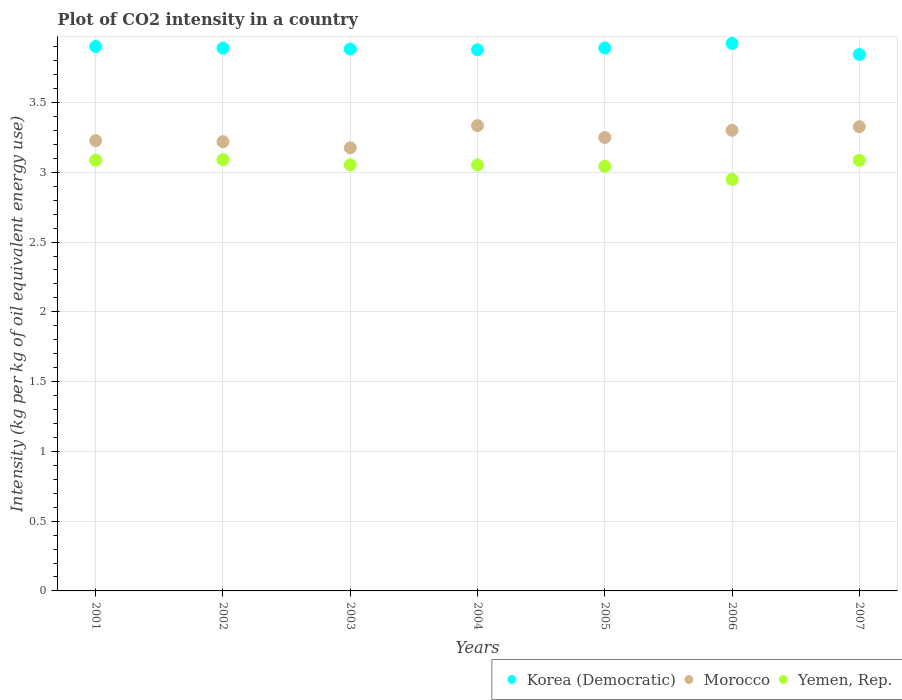What is the CO2 intensity in in Yemen, Rep. in 2001?
Ensure brevity in your answer.  3.09. Across all years, what is the maximum CO2 intensity in in Korea (Democratic)?
Ensure brevity in your answer.  3.92. Across all years, what is the minimum CO2 intensity in in Yemen, Rep.?
Give a very brief answer. 2.95. In which year was the CO2 intensity in in Yemen, Rep. maximum?
Provide a short and direct response. 2002. What is the total CO2 intensity in in Yemen, Rep. in the graph?
Keep it short and to the point. 21.36. What is the difference between the CO2 intensity in in Yemen, Rep. in 2003 and that in 2005?
Your answer should be very brief. 0.01. What is the difference between the CO2 intensity in in Korea (Democratic) in 2001 and the CO2 intensity in in Yemen, Rep. in 2007?
Keep it short and to the point. 0.82. What is the average CO2 intensity in in Yemen, Rep. per year?
Keep it short and to the point. 3.05. In the year 2007, what is the difference between the CO2 intensity in in Yemen, Rep. and CO2 intensity in in Korea (Democratic)?
Your answer should be compact. -0.76. In how many years, is the CO2 intensity in in Korea (Democratic) greater than 3 kg?
Make the answer very short. 7. What is the ratio of the CO2 intensity in in Morocco in 2003 to that in 2004?
Offer a very short reply. 0.95. Is the CO2 intensity in in Yemen, Rep. in 2003 less than that in 2005?
Provide a short and direct response. No. Is the difference between the CO2 intensity in in Yemen, Rep. in 2001 and 2007 greater than the difference between the CO2 intensity in in Korea (Democratic) in 2001 and 2007?
Make the answer very short. No. What is the difference between the highest and the second highest CO2 intensity in in Korea (Democratic)?
Offer a terse response. 0.02. What is the difference between the highest and the lowest CO2 intensity in in Yemen, Rep.?
Give a very brief answer. 0.14. Does the CO2 intensity in in Korea (Democratic) monotonically increase over the years?
Your answer should be very brief. No. Is the CO2 intensity in in Korea (Democratic) strictly greater than the CO2 intensity in in Yemen, Rep. over the years?
Your response must be concise. Yes. How many dotlines are there?
Keep it short and to the point. 3. Are the values on the major ticks of Y-axis written in scientific E-notation?
Give a very brief answer. No. Does the graph contain any zero values?
Keep it short and to the point. No. Where does the legend appear in the graph?
Ensure brevity in your answer.  Bottom right. What is the title of the graph?
Provide a short and direct response. Plot of CO2 intensity in a country. What is the label or title of the Y-axis?
Your answer should be compact. Intensity (kg per kg of oil equivalent energy use). What is the Intensity (kg per kg of oil equivalent energy use) in Korea (Democratic) in 2001?
Provide a succinct answer. 3.9. What is the Intensity (kg per kg of oil equivalent energy use) of Morocco in 2001?
Your response must be concise. 3.23. What is the Intensity (kg per kg of oil equivalent energy use) of Yemen, Rep. in 2001?
Offer a terse response. 3.09. What is the Intensity (kg per kg of oil equivalent energy use) of Korea (Democratic) in 2002?
Provide a short and direct response. 3.89. What is the Intensity (kg per kg of oil equivalent energy use) in Morocco in 2002?
Make the answer very short. 3.22. What is the Intensity (kg per kg of oil equivalent energy use) of Yemen, Rep. in 2002?
Offer a very short reply. 3.09. What is the Intensity (kg per kg of oil equivalent energy use) in Korea (Democratic) in 2003?
Keep it short and to the point. 3.88. What is the Intensity (kg per kg of oil equivalent energy use) of Morocco in 2003?
Make the answer very short. 3.18. What is the Intensity (kg per kg of oil equivalent energy use) of Yemen, Rep. in 2003?
Offer a terse response. 3.05. What is the Intensity (kg per kg of oil equivalent energy use) in Korea (Democratic) in 2004?
Your answer should be compact. 3.88. What is the Intensity (kg per kg of oil equivalent energy use) in Morocco in 2004?
Your answer should be very brief. 3.33. What is the Intensity (kg per kg of oil equivalent energy use) of Yemen, Rep. in 2004?
Provide a succinct answer. 3.05. What is the Intensity (kg per kg of oil equivalent energy use) of Korea (Democratic) in 2005?
Offer a terse response. 3.89. What is the Intensity (kg per kg of oil equivalent energy use) of Morocco in 2005?
Ensure brevity in your answer.  3.25. What is the Intensity (kg per kg of oil equivalent energy use) of Yemen, Rep. in 2005?
Your answer should be compact. 3.04. What is the Intensity (kg per kg of oil equivalent energy use) of Korea (Democratic) in 2006?
Your answer should be very brief. 3.92. What is the Intensity (kg per kg of oil equivalent energy use) of Morocco in 2006?
Offer a very short reply. 3.3. What is the Intensity (kg per kg of oil equivalent energy use) in Yemen, Rep. in 2006?
Give a very brief answer. 2.95. What is the Intensity (kg per kg of oil equivalent energy use) in Korea (Democratic) in 2007?
Offer a terse response. 3.84. What is the Intensity (kg per kg of oil equivalent energy use) in Morocco in 2007?
Ensure brevity in your answer.  3.33. What is the Intensity (kg per kg of oil equivalent energy use) in Yemen, Rep. in 2007?
Offer a very short reply. 3.09. Across all years, what is the maximum Intensity (kg per kg of oil equivalent energy use) of Korea (Democratic)?
Provide a short and direct response. 3.92. Across all years, what is the maximum Intensity (kg per kg of oil equivalent energy use) of Morocco?
Ensure brevity in your answer.  3.33. Across all years, what is the maximum Intensity (kg per kg of oil equivalent energy use) of Yemen, Rep.?
Give a very brief answer. 3.09. Across all years, what is the minimum Intensity (kg per kg of oil equivalent energy use) in Korea (Democratic)?
Ensure brevity in your answer.  3.84. Across all years, what is the minimum Intensity (kg per kg of oil equivalent energy use) of Morocco?
Offer a very short reply. 3.18. Across all years, what is the minimum Intensity (kg per kg of oil equivalent energy use) in Yemen, Rep.?
Your response must be concise. 2.95. What is the total Intensity (kg per kg of oil equivalent energy use) in Korea (Democratic) in the graph?
Provide a succinct answer. 27.21. What is the total Intensity (kg per kg of oil equivalent energy use) in Morocco in the graph?
Your response must be concise. 22.83. What is the total Intensity (kg per kg of oil equivalent energy use) in Yemen, Rep. in the graph?
Provide a short and direct response. 21.36. What is the difference between the Intensity (kg per kg of oil equivalent energy use) in Korea (Democratic) in 2001 and that in 2002?
Your answer should be compact. 0.01. What is the difference between the Intensity (kg per kg of oil equivalent energy use) in Morocco in 2001 and that in 2002?
Your answer should be compact. 0.01. What is the difference between the Intensity (kg per kg of oil equivalent energy use) of Yemen, Rep. in 2001 and that in 2002?
Offer a very short reply. -0. What is the difference between the Intensity (kg per kg of oil equivalent energy use) of Korea (Democratic) in 2001 and that in 2003?
Provide a succinct answer. 0.02. What is the difference between the Intensity (kg per kg of oil equivalent energy use) of Morocco in 2001 and that in 2003?
Ensure brevity in your answer.  0.05. What is the difference between the Intensity (kg per kg of oil equivalent energy use) of Yemen, Rep. in 2001 and that in 2003?
Your answer should be compact. 0.03. What is the difference between the Intensity (kg per kg of oil equivalent energy use) of Korea (Democratic) in 2001 and that in 2004?
Keep it short and to the point. 0.02. What is the difference between the Intensity (kg per kg of oil equivalent energy use) in Morocco in 2001 and that in 2004?
Provide a short and direct response. -0.11. What is the difference between the Intensity (kg per kg of oil equivalent energy use) in Yemen, Rep. in 2001 and that in 2004?
Give a very brief answer. 0.03. What is the difference between the Intensity (kg per kg of oil equivalent energy use) of Korea (Democratic) in 2001 and that in 2005?
Offer a very short reply. 0.01. What is the difference between the Intensity (kg per kg of oil equivalent energy use) in Morocco in 2001 and that in 2005?
Provide a succinct answer. -0.02. What is the difference between the Intensity (kg per kg of oil equivalent energy use) in Yemen, Rep. in 2001 and that in 2005?
Offer a very short reply. 0.04. What is the difference between the Intensity (kg per kg of oil equivalent energy use) in Korea (Democratic) in 2001 and that in 2006?
Make the answer very short. -0.02. What is the difference between the Intensity (kg per kg of oil equivalent energy use) of Morocco in 2001 and that in 2006?
Your response must be concise. -0.07. What is the difference between the Intensity (kg per kg of oil equivalent energy use) of Yemen, Rep. in 2001 and that in 2006?
Provide a short and direct response. 0.14. What is the difference between the Intensity (kg per kg of oil equivalent energy use) of Korea (Democratic) in 2001 and that in 2007?
Provide a succinct answer. 0.06. What is the difference between the Intensity (kg per kg of oil equivalent energy use) of Morocco in 2001 and that in 2007?
Ensure brevity in your answer.  -0.1. What is the difference between the Intensity (kg per kg of oil equivalent energy use) of Yemen, Rep. in 2001 and that in 2007?
Provide a succinct answer. 0. What is the difference between the Intensity (kg per kg of oil equivalent energy use) of Korea (Democratic) in 2002 and that in 2003?
Provide a short and direct response. 0.01. What is the difference between the Intensity (kg per kg of oil equivalent energy use) in Morocco in 2002 and that in 2003?
Your answer should be very brief. 0.04. What is the difference between the Intensity (kg per kg of oil equivalent energy use) in Yemen, Rep. in 2002 and that in 2003?
Offer a terse response. 0.04. What is the difference between the Intensity (kg per kg of oil equivalent energy use) of Korea (Democratic) in 2002 and that in 2004?
Offer a very short reply. 0.01. What is the difference between the Intensity (kg per kg of oil equivalent energy use) in Morocco in 2002 and that in 2004?
Your answer should be very brief. -0.12. What is the difference between the Intensity (kg per kg of oil equivalent energy use) of Yemen, Rep. in 2002 and that in 2004?
Your answer should be compact. 0.04. What is the difference between the Intensity (kg per kg of oil equivalent energy use) in Korea (Democratic) in 2002 and that in 2005?
Offer a very short reply. -0. What is the difference between the Intensity (kg per kg of oil equivalent energy use) of Morocco in 2002 and that in 2005?
Your answer should be very brief. -0.03. What is the difference between the Intensity (kg per kg of oil equivalent energy use) of Yemen, Rep. in 2002 and that in 2005?
Offer a very short reply. 0.05. What is the difference between the Intensity (kg per kg of oil equivalent energy use) of Korea (Democratic) in 2002 and that in 2006?
Your answer should be compact. -0.03. What is the difference between the Intensity (kg per kg of oil equivalent energy use) in Morocco in 2002 and that in 2006?
Your answer should be compact. -0.08. What is the difference between the Intensity (kg per kg of oil equivalent energy use) of Yemen, Rep. in 2002 and that in 2006?
Make the answer very short. 0.14. What is the difference between the Intensity (kg per kg of oil equivalent energy use) of Korea (Democratic) in 2002 and that in 2007?
Provide a succinct answer. 0.05. What is the difference between the Intensity (kg per kg of oil equivalent energy use) in Morocco in 2002 and that in 2007?
Make the answer very short. -0.11. What is the difference between the Intensity (kg per kg of oil equivalent energy use) of Yemen, Rep. in 2002 and that in 2007?
Your answer should be compact. 0.01. What is the difference between the Intensity (kg per kg of oil equivalent energy use) of Korea (Democratic) in 2003 and that in 2004?
Keep it short and to the point. 0.01. What is the difference between the Intensity (kg per kg of oil equivalent energy use) in Morocco in 2003 and that in 2004?
Ensure brevity in your answer.  -0.16. What is the difference between the Intensity (kg per kg of oil equivalent energy use) of Yemen, Rep. in 2003 and that in 2004?
Make the answer very short. 0. What is the difference between the Intensity (kg per kg of oil equivalent energy use) in Korea (Democratic) in 2003 and that in 2005?
Keep it short and to the point. -0.01. What is the difference between the Intensity (kg per kg of oil equivalent energy use) in Morocco in 2003 and that in 2005?
Your answer should be compact. -0.07. What is the difference between the Intensity (kg per kg of oil equivalent energy use) of Yemen, Rep. in 2003 and that in 2005?
Provide a succinct answer. 0.01. What is the difference between the Intensity (kg per kg of oil equivalent energy use) in Korea (Democratic) in 2003 and that in 2006?
Your answer should be compact. -0.04. What is the difference between the Intensity (kg per kg of oil equivalent energy use) of Morocco in 2003 and that in 2006?
Make the answer very short. -0.13. What is the difference between the Intensity (kg per kg of oil equivalent energy use) of Yemen, Rep. in 2003 and that in 2006?
Offer a terse response. 0.11. What is the difference between the Intensity (kg per kg of oil equivalent energy use) in Korea (Democratic) in 2003 and that in 2007?
Offer a very short reply. 0.04. What is the difference between the Intensity (kg per kg of oil equivalent energy use) of Morocco in 2003 and that in 2007?
Make the answer very short. -0.15. What is the difference between the Intensity (kg per kg of oil equivalent energy use) of Yemen, Rep. in 2003 and that in 2007?
Make the answer very short. -0.03. What is the difference between the Intensity (kg per kg of oil equivalent energy use) of Korea (Democratic) in 2004 and that in 2005?
Provide a succinct answer. -0.01. What is the difference between the Intensity (kg per kg of oil equivalent energy use) of Morocco in 2004 and that in 2005?
Keep it short and to the point. 0.08. What is the difference between the Intensity (kg per kg of oil equivalent energy use) of Yemen, Rep. in 2004 and that in 2005?
Your response must be concise. 0.01. What is the difference between the Intensity (kg per kg of oil equivalent energy use) in Korea (Democratic) in 2004 and that in 2006?
Ensure brevity in your answer.  -0.05. What is the difference between the Intensity (kg per kg of oil equivalent energy use) of Morocco in 2004 and that in 2006?
Provide a short and direct response. 0.03. What is the difference between the Intensity (kg per kg of oil equivalent energy use) in Yemen, Rep. in 2004 and that in 2006?
Give a very brief answer. 0.1. What is the difference between the Intensity (kg per kg of oil equivalent energy use) of Korea (Democratic) in 2004 and that in 2007?
Your answer should be very brief. 0.03. What is the difference between the Intensity (kg per kg of oil equivalent energy use) of Morocco in 2004 and that in 2007?
Your answer should be very brief. 0.01. What is the difference between the Intensity (kg per kg of oil equivalent energy use) in Yemen, Rep. in 2004 and that in 2007?
Offer a very short reply. -0.03. What is the difference between the Intensity (kg per kg of oil equivalent energy use) in Korea (Democratic) in 2005 and that in 2006?
Give a very brief answer. -0.03. What is the difference between the Intensity (kg per kg of oil equivalent energy use) of Morocco in 2005 and that in 2006?
Offer a terse response. -0.05. What is the difference between the Intensity (kg per kg of oil equivalent energy use) of Yemen, Rep. in 2005 and that in 2006?
Provide a succinct answer. 0.09. What is the difference between the Intensity (kg per kg of oil equivalent energy use) in Korea (Democratic) in 2005 and that in 2007?
Provide a short and direct response. 0.05. What is the difference between the Intensity (kg per kg of oil equivalent energy use) in Morocco in 2005 and that in 2007?
Your answer should be very brief. -0.08. What is the difference between the Intensity (kg per kg of oil equivalent energy use) in Yemen, Rep. in 2005 and that in 2007?
Ensure brevity in your answer.  -0.04. What is the difference between the Intensity (kg per kg of oil equivalent energy use) in Korea (Democratic) in 2006 and that in 2007?
Offer a very short reply. 0.08. What is the difference between the Intensity (kg per kg of oil equivalent energy use) in Morocco in 2006 and that in 2007?
Provide a short and direct response. -0.03. What is the difference between the Intensity (kg per kg of oil equivalent energy use) of Yemen, Rep. in 2006 and that in 2007?
Provide a short and direct response. -0.14. What is the difference between the Intensity (kg per kg of oil equivalent energy use) of Korea (Democratic) in 2001 and the Intensity (kg per kg of oil equivalent energy use) of Morocco in 2002?
Give a very brief answer. 0.68. What is the difference between the Intensity (kg per kg of oil equivalent energy use) of Korea (Democratic) in 2001 and the Intensity (kg per kg of oil equivalent energy use) of Yemen, Rep. in 2002?
Give a very brief answer. 0.81. What is the difference between the Intensity (kg per kg of oil equivalent energy use) in Morocco in 2001 and the Intensity (kg per kg of oil equivalent energy use) in Yemen, Rep. in 2002?
Give a very brief answer. 0.14. What is the difference between the Intensity (kg per kg of oil equivalent energy use) of Korea (Democratic) in 2001 and the Intensity (kg per kg of oil equivalent energy use) of Morocco in 2003?
Your answer should be compact. 0.73. What is the difference between the Intensity (kg per kg of oil equivalent energy use) of Korea (Democratic) in 2001 and the Intensity (kg per kg of oil equivalent energy use) of Yemen, Rep. in 2003?
Ensure brevity in your answer.  0.85. What is the difference between the Intensity (kg per kg of oil equivalent energy use) of Morocco in 2001 and the Intensity (kg per kg of oil equivalent energy use) of Yemen, Rep. in 2003?
Offer a very short reply. 0.17. What is the difference between the Intensity (kg per kg of oil equivalent energy use) of Korea (Democratic) in 2001 and the Intensity (kg per kg of oil equivalent energy use) of Morocco in 2004?
Your answer should be very brief. 0.57. What is the difference between the Intensity (kg per kg of oil equivalent energy use) of Korea (Democratic) in 2001 and the Intensity (kg per kg of oil equivalent energy use) of Yemen, Rep. in 2004?
Offer a terse response. 0.85. What is the difference between the Intensity (kg per kg of oil equivalent energy use) in Morocco in 2001 and the Intensity (kg per kg of oil equivalent energy use) in Yemen, Rep. in 2004?
Your answer should be very brief. 0.17. What is the difference between the Intensity (kg per kg of oil equivalent energy use) of Korea (Democratic) in 2001 and the Intensity (kg per kg of oil equivalent energy use) of Morocco in 2005?
Your response must be concise. 0.65. What is the difference between the Intensity (kg per kg of oil equivalent energy use) in Korea (Democratic) in 2001 and the Intensity (kg per kg of oil equivalent energy use) in Yemen, Rep. in 2005?
Provide a succinct answer. 0.86. What is the difference between the Intensity (kg per kg of oil equivalent energy use) in Morocco in 2001 and the Intensity (kg per kg of oil equivalent energy use) in Yemen, Rep. in 2005?
Offer a very short reply. 0.18. What is the difference between the Intensity (kg per kg of oil equivalent energy use) in Korea (Democratic) in 2001 and the Intensity (kg per kg of oil equivalent energy use) in Morocco in 2006?
Provide a short and direct response. 0.6. What is the difference between the Intensity (kg per kg of oil equivalent energy use) in Korea (Democratic) in 2001 and the Intensity (kg per kg of oil equivalent energy use) in Yemen, Rep. in 2006?
Offer a terse response. 0.95. What is the difference between the Intensity (kg per kg of oil equivalent energy use) of Morocco in 2001 and the Intensity (kg per kg of oil equivalent energy use) of Yemen, Rep. in 2006?
Offer a very short reply. 0.28. What is the difference between the Intensity (kg per kg of oil equivalent energy use) in Korea (Democratic) in 2001 and the Intensity (kg per kg of oil equivalent energy use) in Morocco in 2007?
Your answer should be very brief. 0.58. What is the difference between the Intensity (kg per kg of oil equivalent energy use) of Korea (Democratic) in 2001 and the Intensity (kg per kg of oil equivalent energy use) of Yemen, Rep. in 2007?
Your answer should be compact. 0.82. What is the difference between the Intensity (kg per kg of oil equivalent energy use) in Morocco in 2001 and the Intensity (kg per kg of oil equivalent energy use) in Yemen, Rep. in 2007?
Make the answer very short. 0.14. What is the difference between the Intensity (kg per kg of oil equivalent energy use) in Korea (Democratic) in 2002 and the Intensity (kg per kg of oil equivalent energy use) in Morocco in 2003?
Provide a succinct answer. 0.71. What is the difference between the Intensity (kg per kg of oil equivalent energy use) in Korea (Democratic) in 2002 and the Intensity (kg per kg of oil equivalent energy use) in Yemen, Rep. in 2003?
Provide a succinct answer. 0.84. What is the difference between the Intensity (kg per kg of oil equivalent energy use) in Morocco in 2002 and the Intensity (kg per kg of oil equivalent energy use) in Yemen, Rep. in 2003?
Keep it short and to the point. 0.17. What is the difference between the Intensity (kg per kg of oil equivalent energy use) of Korea (Democratic) in 2002 and the Intensity (kg per kg of oil equivalent energy use) of Morocco in 2004?
Ensure brevity in your answer.  0.56. What is the difference between the Intensity (kg per kg of oil equivalent energy use) of Korea (Democratic) in 2002 and the Intensity (kg per kg of oil equivalent energy use) of Yemen, Rep. in 2004?
Provide a succinct answer. 0.84. What is the difference between the Intensity (kg per kg of oil equivalent energy use) of Morocco in 2002 and the Intensity (kg per kg of oil equivalent energy use) of Yemen, Rep. in 2004?
Your answer should be very brief. 0.17. What is the difference between the Intensity (kg per kg of oil equivalent energy use) of Korea (Democratic) in 2002 and the Intensity (kg per kg of oil equivalent energy use) of Morocco in 2005?
Ensure brevity in your answer.  0.64. What is the difference between the Intensity (kg per kg of oil equivalent energy use) of Korea (Democratic) in 2002 and the Intensity (kg per kg of oil equivalent energy use) of Yemen, Rep. in 2005?
Give a very brief answer. 0.85. What is the difference between the Intensity (kg per kg of oil equivalent energy use) in Morocco in 2002 and the Intensity (kg per kg of oil equivalent energy use) in Yemen, Rep. in 2005?
Ensure brevity in your answer.  0.18. What is the difference between the Intensity (kg per kg of oil equivalent energy use) of Korea (Democratic) in 2002 and the Intensity (kg per kg of oil equivalent energy use) of Morocco in 2006?
Offer a terse response. 0.59. What is the difference between the Intensity (kg per kg of oil equivalent energy use) in Korea (Democratic) in 2002 and the Intensity (kg per kg of oil equivalent energy use) in Yemen, Rep. in 2006?
Your answer should be compact. 0.94. What is the difference between the Intensity (kg per kg of oil equivalent energy use) of Morocco in 2002 and the Intensity (kg per kg of oil equivalent energy use) of Yemen, Rep. in 2006?
Provide a succinct answer. 0.27. What is the difference between the Intensity (kg per kg of oil equivalent energy use) in Korea (Democratic) in 2002 and the Intensity (kg per kg of oil equivalent energy use) in Morocco in 2007?
Keep it short and to the point. 0.56. What is the difference between the Intensity (kg per kg of oil equivalent energy use) in Korea (Democratic) in 2002 and the Intensity (kg per kg of oil equivalent energy use) in Yemen, Rep. in 2007?
Provide a succinct answer. 0.8. What is the difference between the Intensity (kg per kg of oil equivalent energy use) in Morocco in 2002 and the Intensity (kg per kg of oil equivalent energy use) in Yemen, Rep. in 2007?
Provide a short and direct response. 0.13. What is the difference between the Intensity (kg per kg of oil equivalent energy use) in Korea (Democratic) in 2003 and the Intensity (kg per kg of oil equivalent energy use) in Morocco in 2004?
Ensure brevity in your answer.  0.55. What is the difference between the Intensity (kg per kg of oil equivalent energy use) of Korea (Democratic) in 2003 and the Intensity (kg per kg of oil equivalent energy use) of Yemen, Rep. in 2004?
Your answer should be compact. 0.83. What is the difference between the Intensity (kg per kg of oil equivalent energy use) of Morocco in 2003 and the Intensity (kg per kg of oil equivalent energy use) of Yemen, Rep. in 2004?
Your answer should be compact. 0.12. What is the difference between the Intensity (kg per kg of oil equivalent energy use) in Korea (Democratic) in 2003 and the Intensity (kg per kg of oil equivalent energy use) in Morocco in 2005?
Provide a succinct answer. 0.63. What is the difference between the Intensity (kg per kg of oil equivalent energy use) in Korea (Democratic) in 2003 and the Intensity (kg per kg of oil equivalent energy use) in Yemen, Rep. in 2005?
Provide a succinct answer. 0.84. What is the difference between the Intensity (kg per kg of oil equivalent energy use) of Morocco in 2003 and the Intensity (kg per kg of oil equivalent energy use) of Yemen, Rep. in 2005?
Ensure brevity in your answer.  0.13. What is the difference between the Intensity (kg per kg of oil equivalent energy use) in Korea (Democratic) in 2003 and the Intensity (kg per kg of oil equivalent energy use) in Morocco in 2006?
Provide a succinct answer. 0.58. What is the difference between the Intensity (kg per kg of oil equivalent energy use) in Korea (Democratic) in 2003 and the Intensity (kg per kg of oil equivalent energy use) in Yemen, Rep. in 2006?
Provide a short and direct response. 0.93. What is the difference between the Intensity (kg per kg of oil equivalent energy use) in Morocco in 2003 and the Intensity (kg per kg of oil equivalent energy use) in Yemen, Rep. in 2006?
Your answer should be very brief. 0.23. What is the difference between the Intensity (kg per kg of oil equivalent energy use) in Korea (Democratic) in 2003 and the Intensity (kg per kg of oil equivalent energy use) in Morocco in 2007?
Give a very brief answer. 0.56. What is the difference between the Intensity (kg per kg of oil equivalent energy use) of Korea (Democratic) in 2003 and the Intensity (kg per kg of oil equivalent energy use) of Yemen, Rep. in 2007?
Your answer should be very brief. 0.8. What is the difference between the Intensity (kg per kg of oil equivalent energy use) of Morocco in 2003 and the Intensity (kg per kg of oil equivalent energy use) of Yemen, Rep. in 2007?
Provide a succinct answer. 0.09. What is the difference between the Intensity (kg per kg of oil equivalent energy use) in Korea (Democratic) in 2004 and the Intensity (kg per kg of oil equivalent energy use) in Morocco in 2005?
Provide a succinct answer. 0.63. What is the difference between the Intensity (kg per kg of oil equivalent energy use) in Korea (Democratic) in 2004 and the Intensity (kg per kg of oil equivalent energy use) in Yemen, Rep. in 2005?
Provide a short and direct response. 0.83. What is the difference between the Intensity (kg per kg of oil equivalent energy use) in Morocco in 2004 and the Intensity (kg per kg of oil equivalent energy use) in Yemen, Rep. in 2005?
Make the answer very short. 0.29. What is the difference between the Intensity (kg per kg of oil equivalent energy use) in Korea (Democratic) in 2004 and the Intensity (kg per kg of oil equivalent energy use) in Morocco in 2006?
Provide a short and direct response. 0.58. What is the difference between the Intensity (kg per kg of oil equivalent energy use) of Korea (Democratic) in 2004 and the Intensity (kg per kg of oil equivalent energy use) of Yemen, Rep. in 2006?
Your response must be concise. 0.93. What is the difference between the Intensity (kg per kg of oil equivalent energy use) in Morocco in 2004 and the Intensity (kg per kg of oil equivalent energy use) in Yemen, Rep. in 2006?
Ensure brevity in your answer.  0.39. What is the difference between the Intensity (kg per kg of oil equivalent energy use) of Korea (Democratic) in 2004 and the Intensity (kg per kg of oil equivalent energy use) of Morocco in 2007?
Your response must be concise. 0.55. What is the difference between the Intensity (kg per kg of oil equivalent energy use) of Korea (Democratic) in 2004 and the Intensity (kg per kg of oil equivalent energy use) of Yemen, Rep. in 2007?
Make the answer very short. 0.79. What is the difference between the Intensity (kg per kg of oil equivalent energy use) of Morocco in 2004 and the Intensity (kg per kg of oil equivalent energy use) of Yemen, Rep. in 2007?
Make the answer very short. 0.25. What is the difference between the Intensity (kg per kg of oil equivalent energy use) in Korea (Democratic) in 2005 and the Intensity (kg per kg of oil equivalent energy use) in Morocco in 2006?
Give a very brief answer. 0.59. What is the difference between the Intensity (kg per kg of oil equivalent energy use) in Korea (Democratic) in 2005 and the Intensity (kg per kg of oil equivalent energy use) in Yemen, Rep. in 2006?
Make the answer very short. 0.94. What is the difference between the Intensity (kg per kg of oil equivalent energy use) of Morocco in 2005 and the Intensity (kg per kg of oil equivalent energy use) of Yemen, Rep. in 2006?
Give a very brief answer. 0.3. What is the difference between the Intensity (kg per kg of oil equivalent energy use) in Korea (Democratic) in 2005 and the Intensity (kg per kg of oil equivalent energy use) in Morocco in 2007?
Offer a terse response. 0.56. What is the difference between the Intensity (kg per kg of oil equivalent energy use) in Korea (Democratic) in 2005 and the Intensity (kg per kg of oil equivalent energy use) in Yemen, Rep. in 2007?
Ensure brevity in your answer.  0.8. What is the difference between the Intensity (kg per kg of oil equivalent energy use) in Morocco in 2005 and the Intensity (kg per kg of oil equivalent energy use) in Yemen, Rep. in 2007?
Give a very brief answer. 0.16. What is the difference between the Intensity (kg per kg of oil equivalent energy use) of Korea (Democratic) in 2006 and the Intensity (kg per kg of oil equivalent energy use) of Morocco in 2007?
Your response must be concise. 0.6. What is the difference between the Intensity (kg per kg of oil equivalent energy use) of Korea (Democratic) in 2006 and the Intensity (kg per kg of oil equivalent energy use) of Yemen, Rep. in 2007?
Make the answer very short. 0.84. What is the difference between the Intensity (kg per kg of oil equivalent energy use) in Morocco in 2006 and the Intensity (kg per kg of oil equivalent energy use) in Yemen, Rep. in 2007?
Provide a succinct answer. 0.21. What is the average Intensity (kg per kg of oil equivalent energy use) of Korea (Democratic) per year?
Offer a very short reply. 3.89. What is the average Intensity (kg per kg of oil equivalent energy use) of Morocco per year?
Provide a succinct answer. 3.26. What is the average Intensity (kg per kg of oil equivalent energy use) in Yemen, Rep. per year?
Your answer should be very brief. 3.05. In the year 2001, what is the difference between the Intensity (kg per kg of oil equivalent energy use) of Korea (Democratic) and Intensity (kg per kg of oil equivalent energy use) of Morocco?
Your answer should be very brief. 0.67. In the year 2001, what is the difference between the Intensity (kg per kg of oil equivalent energy use) in Korea (Democratic) and Intensity (kg per kg of oil equivalent energy use) in Yemen, Rep.?
Offer a terse response. 0.81. In the year 2001, what is the difference between the Intensity (kg per kg of oil equivalent energy use) of Morocco and Intensity (kg per kg of oil equivalent energy use) of Yemen, Rep.?
Give a very brief answer. 0.14. In the year 2002, what is the difference between the Intensity (kg per kg of oil equivalent energy use) in Korea (Democratic) and Intensity (kg per kg of oil equivalent energy use) in Morocco?
Provide a succinct answer. 0.67. In the year 2002, what is the difference between the Intensity (kg per kg of oil equivalent energy use) of Korea (Democratic) and Intensity (kg per kg of oil equivalent energy use) of Yemen, Rep.?
Your answer should be very brief. 0.8. In the year 2002, what is the difference between the Intensity (kg per kg of oil equivalent energy use) in Morocco and Intensity (kg per kg of oil equivalent energy use) in Yemen, Rep.?
Your answer should be compact. 0.13. In the year 2003, what is the difference between the Intensity (kg per kg of oil equivalent energy use) of Korea (Democratic) and Intensity (kg per kg of oil equivalent energy use) of Morocco?
Keep it short and to the point. 0.71. In the year 2003, what is the difference between the Intensity (kg per kg of oil equivalent energy use) of Korea (Democratic) and Intensity (kg per kg of oil equivalent energy use) of Yemen, Rep.?
Provide a short and direct response. 0.83. In the year 2003, what is the difference between the Intensity (kg per kg of oil equivalent energy use) in Morocco and Intensity (kg per kg of oil equivalent energy use) in Yemen, Rep.?
Keep it short and to the point. 0.12. In the year 2004, what is the difference between the Intensity (kg per kg of oil equivalent energy use) of Korea (Democratic) and Intensity (kg per kg of oil equivalent energy use) of Morocco?
Your answer should be very brief. 0.54. In the year 2004, what is the difference between the Intensity (kg per kg of oil equivalent energy use) in Korea (Democratic) and Intensity (kg per kg of oil equivalent energy use) in Yemen, Rep.?
Offer a very short reply. 0.82. In the year 2004, what is the difference between the Intensity (kg per kg of oil equivalent energy use) in Morocco and Intensity (kg per kg of oil equivalent energy use) in Yemen, Rep.?
Your answer should be compact. 0.28. In the year 2005, what is the difference between the Intensity (kg per kg of oil equivalent energy use) of Korea (Democratic) and Intensity (kg per kg of oil equivalent energy use) of Morocco?
Offer a very short reply. 0.64. In the year 2005, what is the difference between the Intensity (kg per kg of oil equivalent energy use) of Korea (Democratic) and Intensity (kg per kg of oil equivalent energy use) of Yemen, Rep.?
Provide a short and direct response. 0.85. In the year 2005, what is the difference between the Intensity (kg per kg of oil equivalent energy use) in Morocco and Intensity (kg per kg of oil equivalent energy use) in Yemen, Rep.?
Keep it short and to the point. 0.21. In the year 2006, what is the difference between the Intensity (kg per kg of oil equivalent energy use) of Korea (Democratic) and Intensity (kg per kg of oil equivalent energy use) of Morocco?
Provide a short and direct response. 0.62. In the year 2006, what is the difference between the Intensity (kg per kg of oil equivalent energy use) of Morocco and Intensity (kg per kg of oil equivalent energy use) of Yemen, Rep.?
Give a very brief answer. 0.35. In the year 2007, what is the difference between the Intensity (kg per kg of oil equivalent energy use) in Korea (Democratic) and Intensity (kg per kg of oil equivalent energy use) in Morocco?
Your answer should be very brief. 0.52. In the year 2007, what is the difference between the Intensity (kg per kg of oil equivalent energy use) in Korea (Democratic) and Intensity (kg per kg of oil equivalent energy use) in Yemen, Rep.?
Give a very brief answer. 0.76. In the year 2007, what is the difference between the Intensity (kg per kg of oil equivalent energy use) in Morocco and Intensity (kg per kg of oil equivalent energy use) in Yemen, Rep.?
Your answer should be compact. 0.24. What is the ratio of the Intensity (kg per kg of oil equivalent energy use) in Korea (Democratic) in 2001 to that in 2002?
Give a very brief answer. 1. What is the ratio of the Intensity (kg per kg of oil equivalent energy use) in Morocco in 2001 to that in 2002?
Keep it short and to the point. 1. What is the ratio of the Intensity (kg per kg of oil equivalent energy use) in Yemen, Rep. in 2001 to that in 2002?
Your answer should be compact. 1. What is the ratio of the Intensity (kg per kg of oil equivalent energy use) of Korea (Democratic) in 2001 to that in 2003?
Give a very brief answer. 1. What is the ratio of the Intensity (kg per kg of oil equivalent energy use) in Morocco in 2001 to that in 2003?
Provide a short and direct response. 1.02. What is the ratio of the Intensity (kg per kg of oil equivalent energy use) of Yemen, Rep. in 2001 to that in 2003?
Keep it short and to the point. 1.01. What is the ratio of the Intensity (kg per kg of oil equivalent energy use) in Korea (Democratic) in 2001 to that in 2004?
Your answer should be compact. 1.01. What is the ratio of the Intensity (kg per kg of oil equivalent energy use) in Morocco in 2001 to that in 2004?
Provide a succinct answer. 0.97. What is the ratio of the Intensity (kg per kg of oil equivalent energy use) of Yemen, Rep. in 2001 to that in 2004?
Your answer should be very brief. 1.01. What is the ratio of the Intensity (kg per kg of oil equivalent energy use) of Yemen, Rep. in 2001 to that in 2005?
Give a very brief answer. 1.01. What is the ratio of the Intensity (kg per kg of oil equivalent energy use) of Morocco in 2001 to that in 2006?
Make the answer very short. 0.98. What is the ratio of the Intensity (kg per kg of oil equivalent energy use) of Yemen, Rep. in 2001 to that in 2006?
Ensure brevity in your answer.  1.05. What is the ratio of the Intensity (kg per kg of oil equivalent energy use) of Morocco in 2001 to that in 2007?
Your response must be concise. 0.97. What is the ratio of the Intensity (kg per kg of oil equivalent energy use) in Yemen, Rep. in 2001 to that in 2007?
Provide a succinct answer. 1. What is the ratio of the Intensity (kg per kg of oil equivalent energy use) of Morocco in 2002 to that in 2003?
Ensure brevity in your answer.  1.01. What is the ratio of the Intensity (kg per kg of oil equivalent energy use) in Yemen, Rep. in 2002 to that in 2003?
Give a very brief answer. 1.01. What is the ratio of the Intensity (kg per kg of oil equivalent energy use) in Korea (Democratic) in 2002 to that in 2004?
Provide a succinct answer. 1. What is the ratio of the Intensity (kg per kg of oil equivalent energy use) in Morocco in 2002 to that in 2004?
Provide a short and direct response. 0.97. What is the ratio of the Intensity (kg per kg of oil equivalent energy use) in Yemen, Rep. in 2002 to that in 2004?
Your answer should be very brief. 1.01. What is the ratio of the Intensity (kg per kg of oil equivalent energy use) in Korea (Democratic) in 2002 to that in 2005?
Your answer should be very brief. 1. What is the ratio of the Intensity (kg per kg of oil equivalent energy use) in Yemen, Rep. in 2002 to that in 2005?
Give a very brief answer. 1.02. What is the ratio of the Intensity (kg per kg of oil equivalent energy use) of Korea (Democratic) in 2002 to that in 2006?
Your answer should be compact. 0.99. What is the ratio of the Intensity (kg per kg of oil equivalent energy use) in Morocco in 2002 to that in 2006?
Ensure brevity in your answer.  0.98. What is the ratio of the Intensity (kg per kg of oil equivalent energy use) of Yemen, Rep. in 2002 to that in 2006?
Provide a succinct answer. 1.05. What is the ratio of the Intensity (kg per kg of oil equivalent energy use) of Korea (Democratic) in 2002 to that in 2007?
Offer a very short reply. 1.01. What is the ratio of the Intensity (kg per kg of oil equivalent energy use) in Morocco in 2002 to that in 2007?
Keep it short and to the point. 0.97. What is the ratio of the Intensity (kg per kg of oil equivalent energy use) in Korea (Democratic) in 2003 to that in 2004?
Make the answer very short. 1. What is the ratio of the Intensity (kg per kg of oil equivalent energy use) in Morocco in 2003 to that in 2004?
Ensure brevity in your answer.  0.95. What is the ratio of the Intensity (kg per kg of oil equivalent energy use) of Yemen, Rep. in 2003 to that in 2004?
Offer a terse response. 1. What is the ratio of the Intensity (kg per kg of oil equivalent energy use) of Korea (Democratic) in 2003 to that in 2005?
Offer a very short reply. 1. What is the ratio of the Intensity (kg per kg of oil equivalent energy use) of Morocco in 2003 to that in 2005?
Provide a succinct answer. 0.98. What is the ratio of the Intensity (kg per kg of oil equivalent energy use) of Korea (Democratic) in 2003 to that in 2006?
Your answer should be compact. 0.99. What is the ratio of the Intensity (kg per kg of oil equivalent energy use) in Morocco in 2003 to that in 2006?
Keep it short and to the point. 0.96. What is the ratio of the Intensity (kg per kg of oil equivalent energy use) in Yemen, Rep. in 2003 to that in 2006?
Ensure brevity in your answer.  1.04. What is the ratio of the Intensity (kg per kg of oil equivalent energy use) in Korea (Democratic) in 2003 to that in 2007?
Make the answer very short. 1.01. What is the ratio of the Intensity (kg per kg of oil equivalent energy use) of Morocco in 2003 to that in 2007?
Offer a very short reply. 0.95. What is the ratio of the Intensity (kg per kg of oil equivalent energy use) in Yemen, Rep. in 2003 to that in 2007?
Your answer should be very brief. 0.99. What is the ratio of the Intensity (kg per kg of oil equivalent energy use) of Morocco in 2004 to that in 2005?
Make the answer very short. 1.03. What is the ratio of the Intensity (kg per kg of oil equivalent energy use) in Morocco in 2004 to that in 2006?
Your response must be concise. 1.01. What is the ratio of the Intensity (kg per kg of oil equivalent energy use) in Yemen, Rep. in 2004 to that in 2006?
Your response must be concise. 1.04. What is the ratio of the Intensity (kg per kg of oil equivalent energy use) in Korea (Democratic) in 2004 to that in 2007?
Offer a very short reply. 1.01. What is the ratio of the Intensity (kg per kg of oil equivalent energy use) of Morocco in 2004 to that in 2007?
Your answer should be compact. 1. What is the ratio of the Intensity (kg per kg of oil equivalent energy use) of Yemen, Rep. in 2004 to that in 2007?
Your answer should be very brief. 0.99. What is the ratio of the Intensity (kg per kg of oil equivalent energy use) of Korea (Democratic) in 2005 to that in 2006?
Your response must be concise. 0.99. What is the ratio of the Intensity (kg per kg of oil equivalent energy use) of Morocco in 2005 to that in 2006?
Make the answer very short. 0.98. What is the ratio of the Intensity (kg per kg of oil equivalent energy use) in Yemen, Rep. in 2005 to that in 2006?
Your response must be concise. 1.03. What is the ratio of the Intensity (kg per kg of oil equivalent energy use) in Korea (Democratic) in 2005 to that in 2007?
Your response must be concise. 1.01. What is the ratio of the Intensity (kg per kg of oil equivalent energy use) of Morocco in 2005 to that in 2007?
Provide a succinct answer. 0.98. What is the ratio of the Intensity (kg per kg of oil equivalent energy use) of Yemen, Rep. in 2005 to that in 2007?
Your answer should be very brief. 0.99. What is the ratio of the Intensity (kg per kg of oil equivalent energy use) in Korea (Democratic) in 2006 to that in 2007?
Make the answer very short. 1.02. What is the ratio of the Intensity (kg per kg of oil equivalent energy use) in Morocco in 2006 to that in 2007?
Your answer should be very brief. 0.99. What is the ratio of the Intensity (kg per kg of oil equivalent energy use) in Yemen, Rep. in 2006 to that in 2007?
Make the answer very short. 0.96. What is the difference between the highest and the second highest Intensity (kg per kg of oil equivalent energy use) of Korea (Democratic)?
Your answer should be very brief. 0.02. What is the difference between the highest and the second highest Intensity (kg per kg of oil equivalent energy use) of Morocco?
Ensure brevity in your answer.  0.01. What is the difference between the highest and the second highest Intensity (kg per kg of oil equivalent energy use) of Yemen, Rep.?
Ensure brevity in your answer.  0. What is the difference between the highest and the lowest Intensity (kg per kg of oil equivalent energy use) of Korea (Democratic)?
Give a very brief answer. 0.08. What is the difference between the highest and the lowest Intensity (kg per kg of oil equivalent energy use) in Morocco?
Keep it short and to the point. 0.16. What is the difference between the highest and the lowest Intensity (kg per kg of oil equivalent energy use) in Yemen, Rep.?
Your answer should be compact. 0.14. 